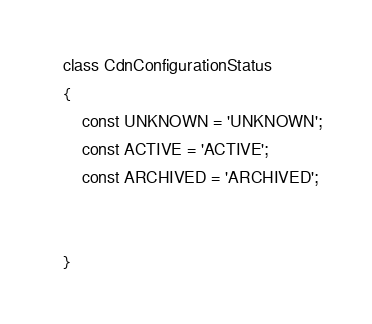Convert code to text. <code><loc_0><loc_0><loc_500><loc_500><_PHP_>class CdnConfigurationStatus
{
    const UNKNOWN = 'UNKNOWN';
    const ACTIVE = 'ACTIVE';
    const ARCHIVED = 'ARCHIVED';


}
</code> 